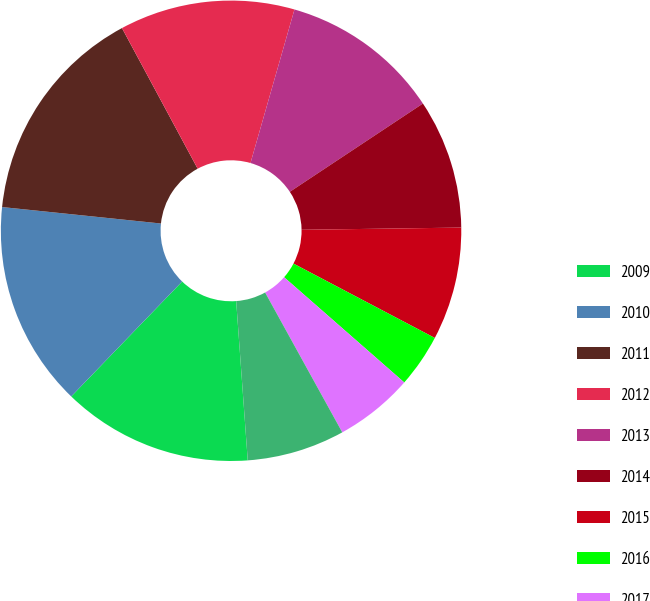Convert chart. <chart><loc_0><loc_0><loc_500><loc_500><pie_chart><fcel>2009<fcel>2010<fcel>2011<fcel>2012<fcel>2013<fcel>2014<fcel>2015<fcel>2016<fcel>2017<fcel>2018<nl><fcel>13.37%<fcel>14.43%<fcel>15.5%<fcel>12.3%<fcel>11.24%<fcel>9.1%<fcel>7.93%<fcel>3.74%<fcel>5.53%<fcel>6.87%<nl></chart> 